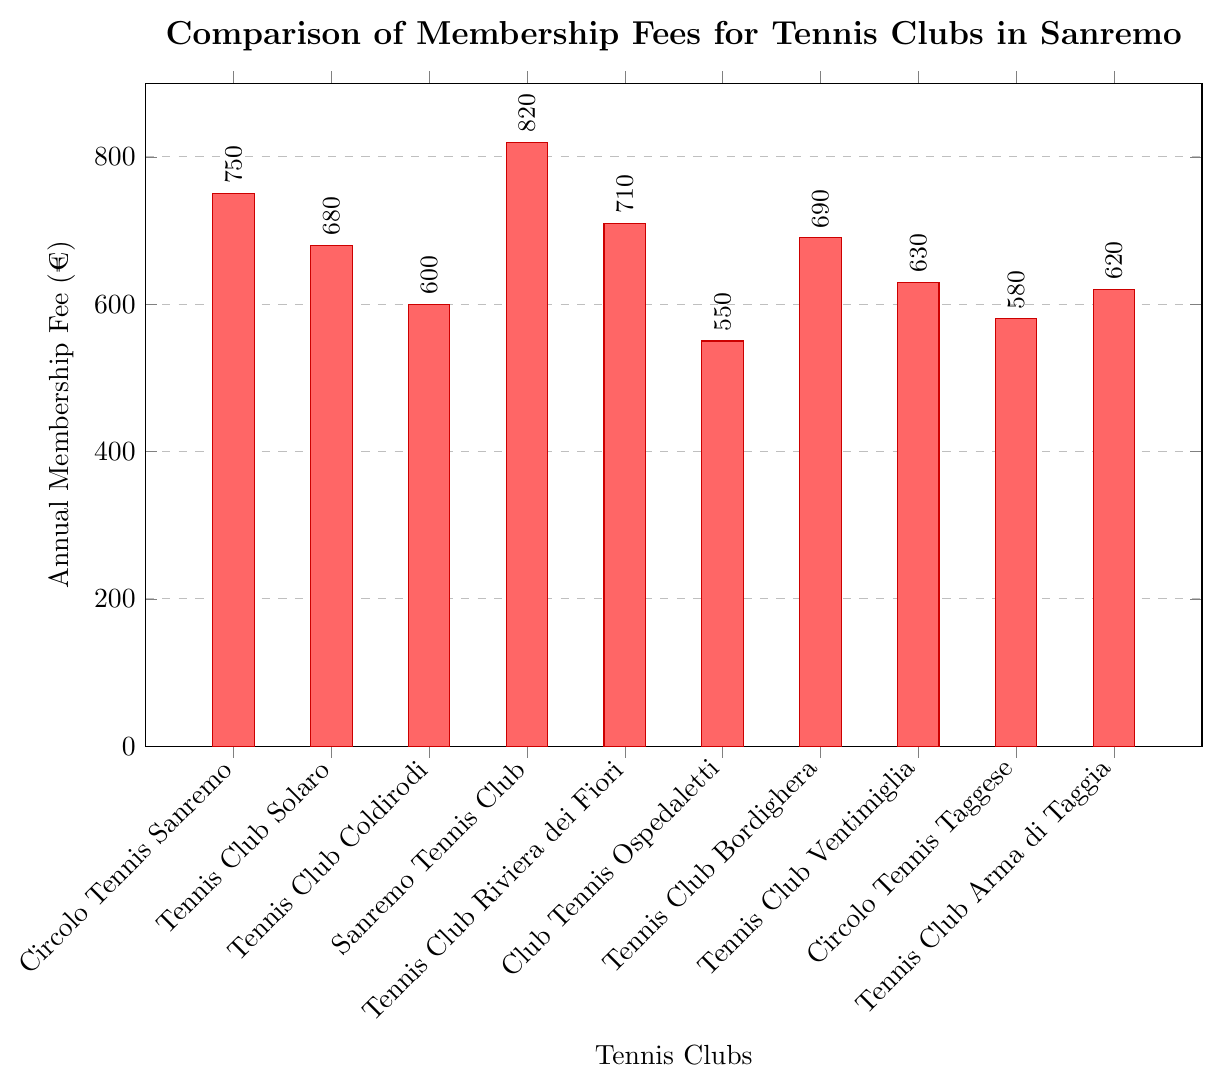What's the highest annual membership fee among the tennis clubs? To find the highest annual membership fee, look for the bar with the greatest height. The Sanremo Tennis Club has the tallest bar reaching 820 €
Answer: 820 € What is the average annual membership fee for all the tennis clubs? Sum all the membership fees and then divide by the number of clubs. (750 + 680 + 600 + 820 + 710 + 550 + 690 + 630 + 580 + 620) / 10 = 6630 / 10 = 663 €
Answer: 663 € How much more expensive is the membership of Circolo Tennis Sanremo compared to Tennis Club Ventimiglia? Subtract the membership fee of Tennis Club Ventimiglia from that of Circolo Tennis Sanremo. 750 € - 630 € = 120 €
Answer: 120 € Which two tennis clubs have the closest annual membership fees? Compare the differences between the membership fees of each pair of clubs. Circolo Tennis Taggese (580 €) and Tennis Club Arma di Taggia (620 €) have the closest fees, with a difference of 40 €
Answer: Circolo Tennis Taggese and Tennis Club Arma di Taggia What is the total membership fee if one joins Tennis Club Solaro and Tennis Club Bordighera? Add the membership fees of Tennis Club Solaro and Tennis Club Bordighera. 680 € + 690 € = 1370 €
Answer: 1370 € Which tennis club has the lowest annual membership fee? Find the shortest bar in the chart, which represents Club Tennis Ospedaletti with a fee of 550 €
Answer: Club Tennis Ospedaletti What is the range (difference between highest and lowest) of the annual membership fees? Subtract the lowest membership fee from the highest. 820 € (highest) - 550 € (lowest) = 270 €
Answer: 270 € How does the membership fee of Tennis Club Riviera dei Fiori compare with that of Tennis Club Bordighera? Compare the heights of the bars. The fee for Tennis Club Riviera dei Fiori (710 €) is higher than that of Tennis Club Bordighera (690 €) by 20 €
Answer: 20 € If you combine the membership fees of Club Tennis Ospedaletti, Circolo Tennis Taggese, and Tennis Club Coldirodi, what would be the total cost? Add the membership fees of the three clubs. 550 € + 580 € + 600 € = 1730 €
Answer: 1730 € What is the median annual membership fee of the tennis clubs? First, sort the membership fees in ascending order: 550 €, 580 €, 600 €, 620 €, 630 €, 680 €, 690 €, 710 €, 750 €, 820 €. With 10 values, the median is the average of the 5th and 6th values, (630 € + 680 €)/2 = 655 €
Answer: 655 € 